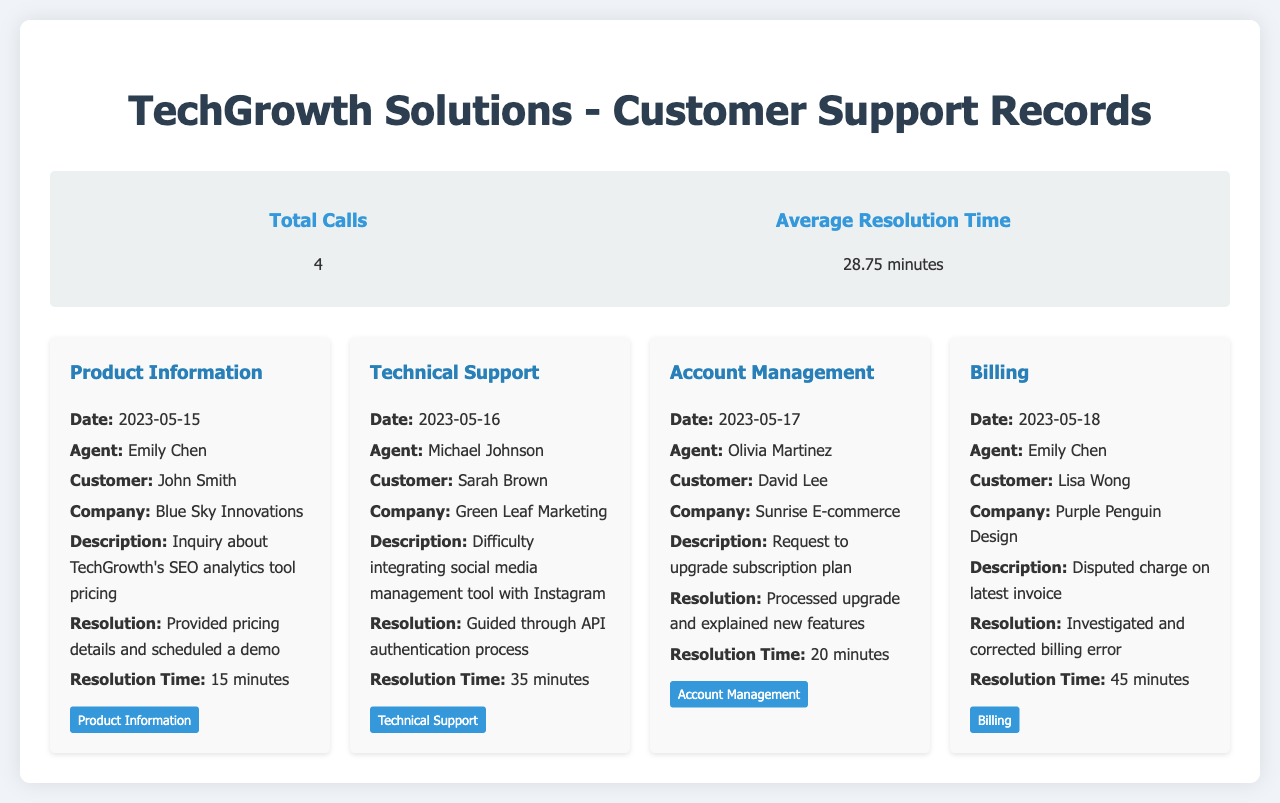What is the total number of calls? The total number of calls is listed in the summary section of the document, which states "4".
Answer: 4 Who handled the call for Product Information? The agent who handled the call for Product Information is mentioned under the record card, which names "Emily Chen".
Answer: Emily Chen What was the resolution time for the Technical Support call? The resolution time for the Technical Support call is specified in the record card and is "35 minutes".
Answer: 35 minutes What company did David Lee represent? David Lee is mentioned in the Account Management record card, which identifies the company as "Sunrise E-commerce".
Answer: Sunrise E-commerce Which issue category had the longest resolution time? The issue categories and their resolution times can be compared; the longest resolution time is "45 minutes" for the Billing category.
Answer: Billing What was the description of the call handled by Olivia Martinez? The description for the call handled by Olivia Martinez is specified in the document as "Request to upgrade subscription plan".
Answer: Request to upgrade subscription plan How many minutes did it take to resolve the Billing issue? The resolution time is clearly stated under the Billing record card, which indicates "45 minutes".
Answer: 45 minutes What date was the call for Account Management made? The date for the Account Management call is specified in the record card, which states "2023-05-17".
Answer: 2023-05-17 What tag corresponds to the call with Sarah Brown? The tag for the call handled with Sarah Brown is indicated in the Technical Support record card as "Technical Support".
Answer: Technical Support 